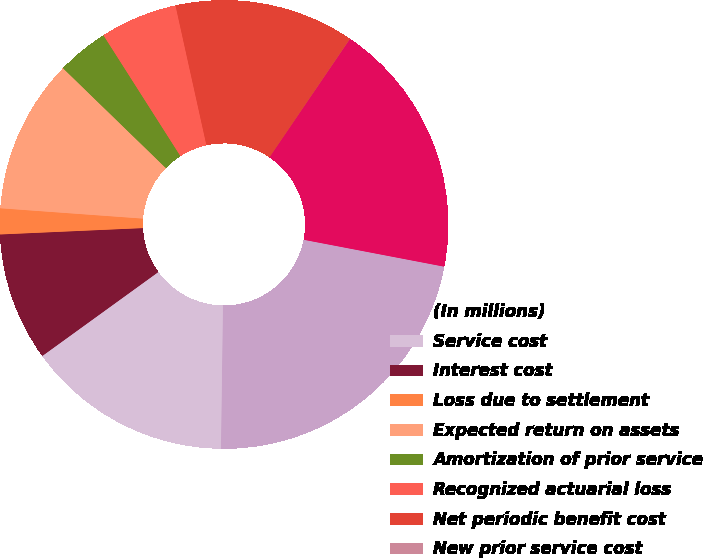<chart> <loc_0><loc_0><loc_500><loc_500><pie_chart><fcel>(In millions)<fcel>Service cost<fcel>Interest cost<fcel>Loss due to settlement<fcel>Expected return on assets<fcel>Amortization of prior service<fcel>Recognized actuarial loss<fcel>Net periodic benefit cost<fcel>New prior service cost<fcel>Net (gain) loss arising during<nl><fcel>22.21%<fcel>14.81%<fcel>9.26%<fcel>1.86%<fcel>11.11%<fcel>3.71%<fcel>5.56%<fcel>12.96%<fcel>0.01%<fcel>18.51%<nl></chart> 